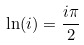<formula> <loc_0><loc_0><loc_500><loc_500>\ln ( i ) = \frac { i \pi } { 2 }</formula> 